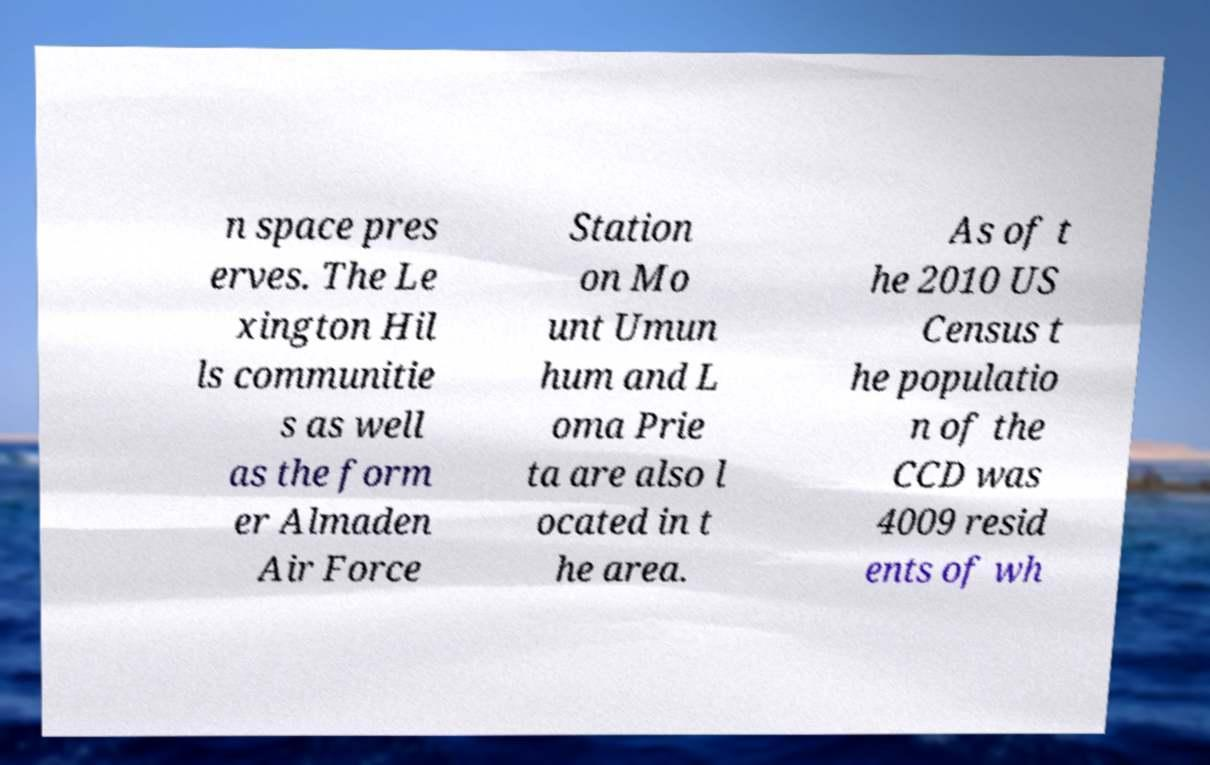Could you assist in decoding the text presented in this image and type it out clearly? n space pres erves. The Le xington Hil ls communitie s as well as the form er Almaden Air Force Station on Mo unt Umun hum and L oma Prie ta are also l ocated in t he area. As of t he 2010 US Census t he populatio n of the CCD was 4009 resid ents of wh 